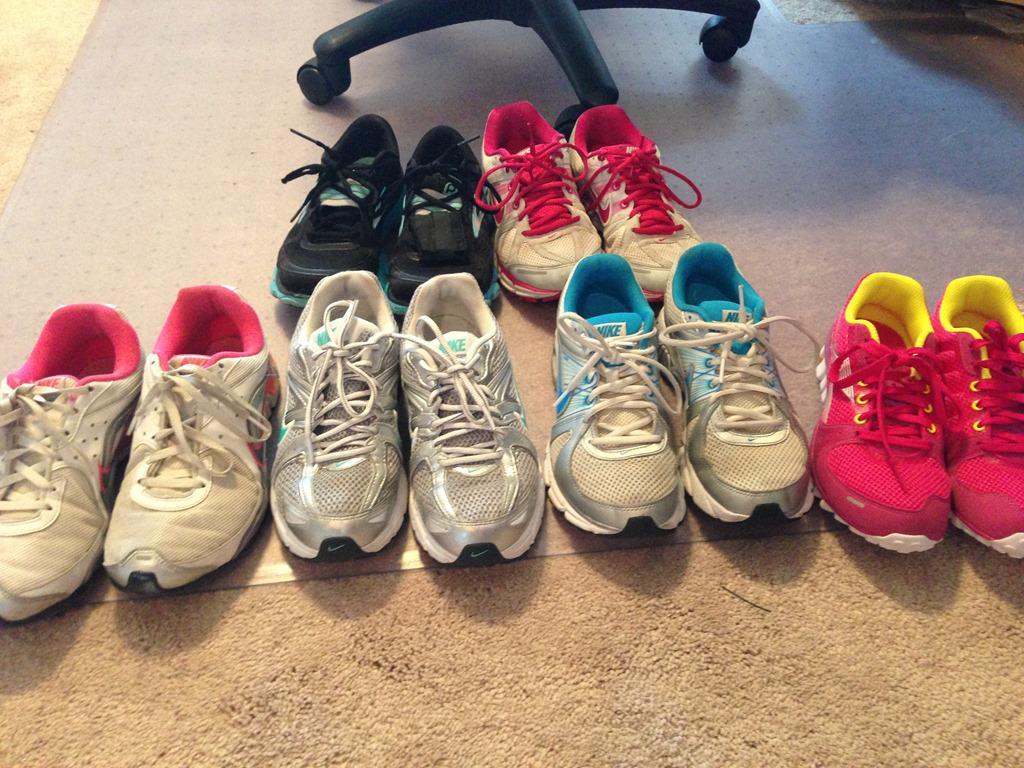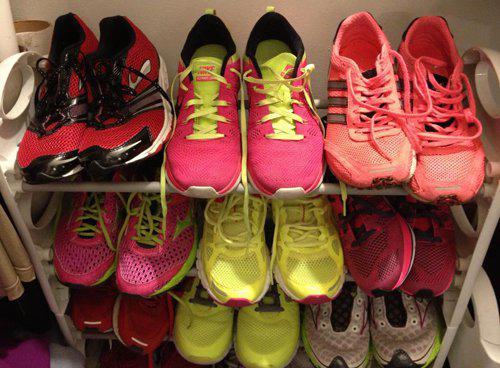The first image is the image on the left, the second image is the image on the right. For the images shown, is this caption "In the image on the left, a red and yellow shoe is sitting on the right side of the row." true? Answer yes or no. Yes. The first image is the image on the left, the second image is the image on the right. Given the left and right images, does the statement "The image on the right in the pair has fewer than five sneakers." hold true? Answer yes or no. No. 